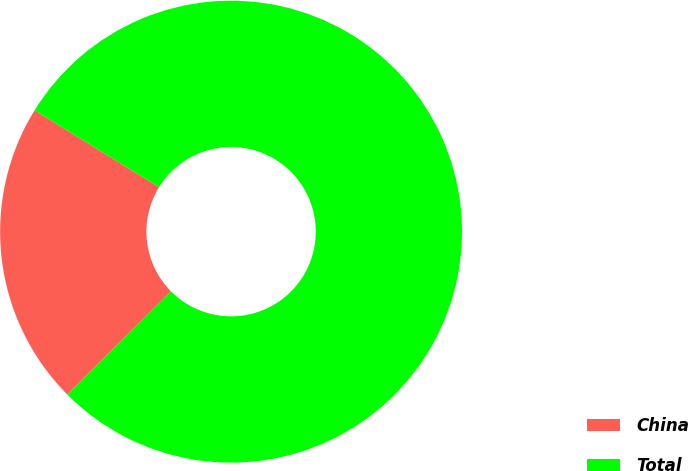Convert chart. <chart><loc_0><loc_0><loc_500><loc_500><pie_chart><fcel>China<fcel>Total<nl><fcel>21.26%<fcel>78.74%<nl></chart> 